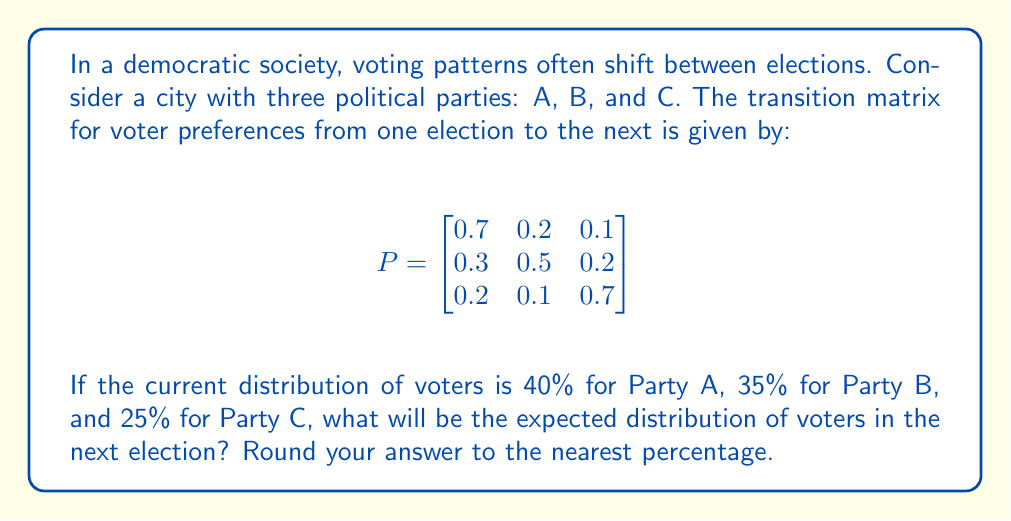Can you solve this math problem? Let's approach this step-by-step:

1) First, we need to represent the current distribution of voters as a row vector:

   $v = \begin{bmatrix} 0.40 & 0.35 & 0.25 \end{bmatrix}$

2) To find the distribution for the next election, we multiply this vector by the transition matrix:

   $v_{next} = v \cdot P$

3) Let's perform this matrix multiplication:

   $v_{next} = \begin{bmatrix} 0.40 & 0.35 & 0.25 \end{bmatrix} \cdot 
   \begin{bmatrix}
   0.7 & 0.2 & 0.1 \\
   0.3 & 0.5 & 0.2 \\
   0.2 & 0.1 & 0.7
   \end{bmatrix}$

4) Calculating each element:
   
   For Party A: $(0.40 \cdot 0.7) + (0.35 \cdot 0.3) + (0.25 \cdot 0.2) = 0.28 + 0.105 + 0.05 = 0.435$
   
   For Party B: $(0.40 \cdot 0.2) + (0.35 \cdot 0.5) + (0.25 \cdot 0.1) = 0.08 + 0.175 + 0.025 = 0.28$
   
   For Party C: $(0.40 \cdot 0.1) + (0.35 \cdot 0.2) + (0.25 \cdot 0.7) = 0.04 + 0.07 + 0.175 = 0.285$

5) Therefore, $v_{next} = \begin{bmatrix} 0.435 & 0.28 & 0.285 \end{bmatrix}$

6) Converting to percentages and rounding to the nearest whole number:
   
   Party A: 43.5% ≈ 44%
   Party B: 28.0% ≈ 28%
   Party C: 28.5% ≈ 29%
Answer: 44% Party A, 28% Party B, 29% Party C 